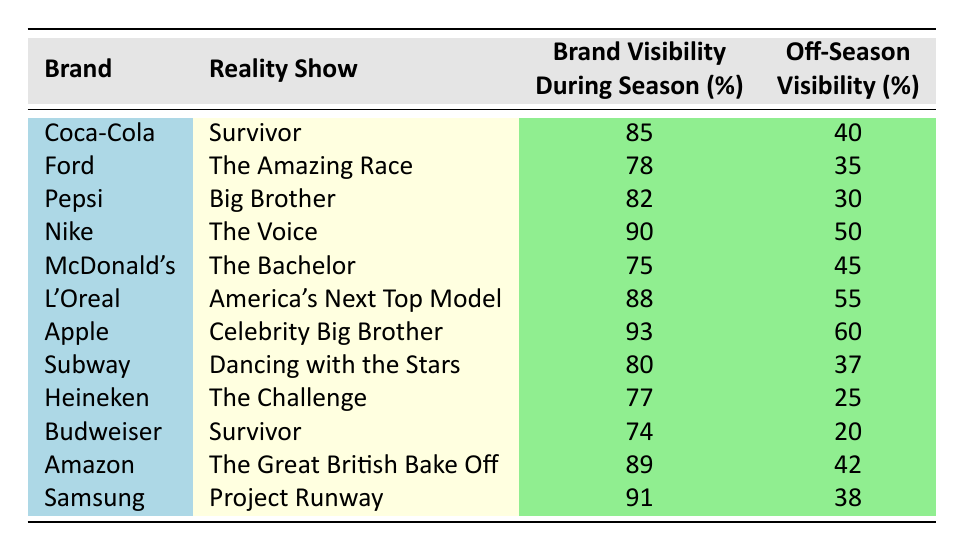What is the brand visibility of Nike during the season? Nike's brand visibility during the season, as shown in the table, is 90%.
Answer: 90% Which brand had the highest off-season visibility? From the table, Apple has the highest off-season visibility at 60%.
Answer: 60% What is the difference in brand visibility between Coca-Cola during the season and off-season? Coca-Cola’s visibility during the season is 85%, while off-season it is 40%. The difference is 85 - 40 = 45%.
Answer: 45% True or false: McDonald's had higher brand visibility during the season than off-season. McDonald's brand visibility during the season is 75% and off-season is 45%. Since 75% is greater than 45%, the statement is true.
Answer: True What is the average brand visibility during the season for brands represented in Survivor? The brands in Survivor are Coca-Cola (85%) and Budweiser (74%). To find the average: (85 + 74) / 2 = 79.5%.
Answer: 79.5% Which brand's off-season visibility is closest to the average off-season visibility of all brands listed? The average off-season visibility of all brands is (40 + 35 + 30 + 50 + 45 + 55 + 60 + 37 + 25 + 20 + 42 + 38) / 12 =  40. The closest value is Subway at 37%.
Answer: 37% If L'Oreal's visibility during the season was improved by 10%, what would that be? L'Oreal's current visibility during the season is 88%. If it's increased by 10%, it would be 88 + 10 = 98%.
Answer: 98% What brand had the lowest visibility during the off-season? The table shows that Heineken has the lowest off-season visibility at 25%.
Answer: 25% Which reality show had the highest brand visibility overall? The table shows that Apple on Celebrity Big Brother had the highest visibility during the season at 93%.
Answer: 93% 